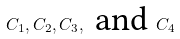<formula> <loc_0><loc_0><loc_500><loc_500>C _ { 1 } , C _ { 2 } , C _ { 3 } , \text { and } C _ { 4 }</formula> 